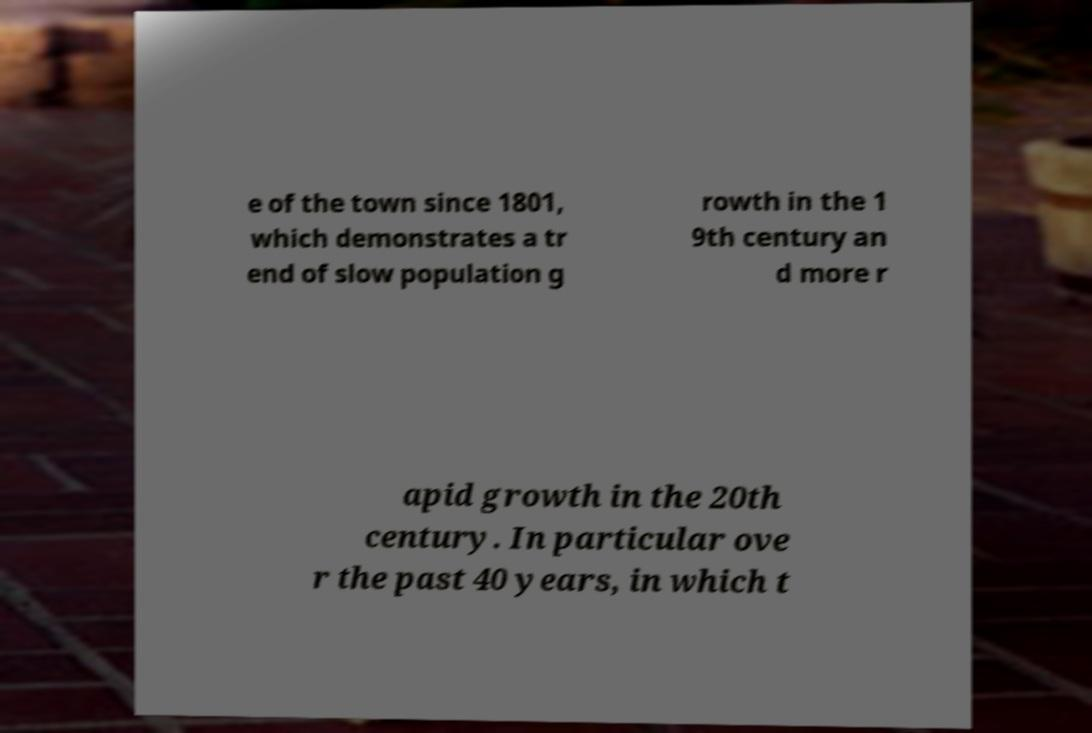There's text embedded in this image that I need extracted. Can you transcribe it verbatim? e of the town since 1801, which demonstrates a tr end of slow population g rowth in the 1 9th century an d more r apid growth in the 20th century. In particular ove r the past 40 years, in which t 